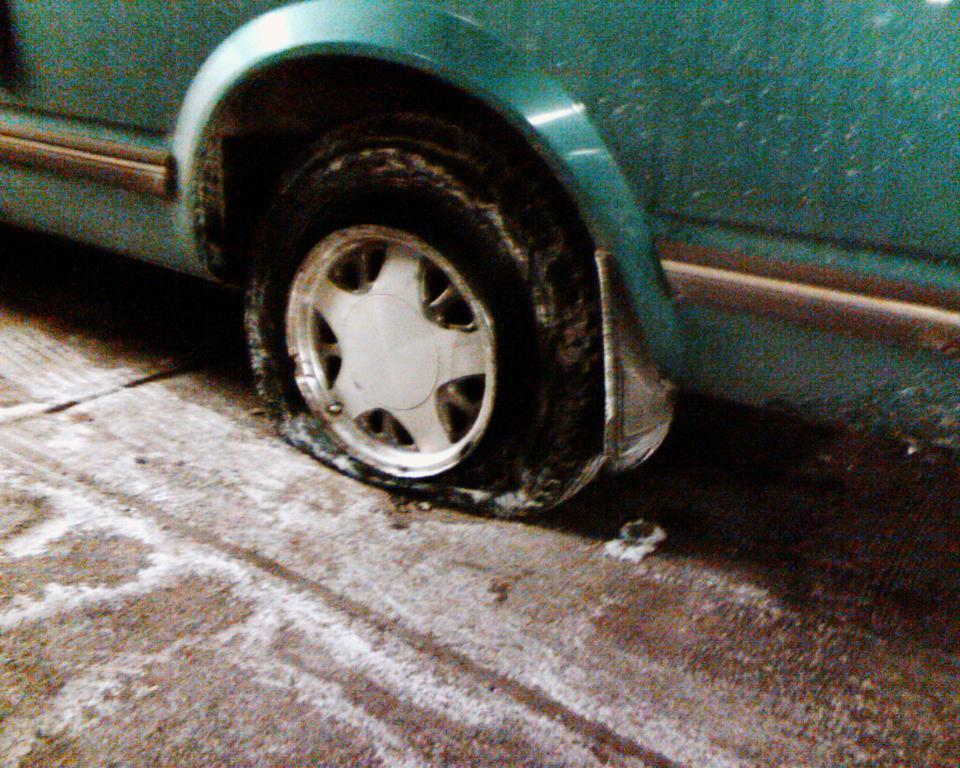Please provide a concise description of this image. In this picture, we see a vehicle in green color. We see the punctured tyre. At the bottom, we see the road. 